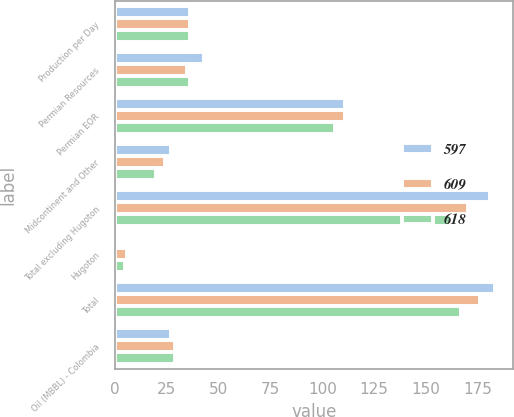Convert chart to OTSL. <chart><loc_0><loc_0><loc_500><loc_500><stacked_bar_chart><ecel><fcel>Production per Day<fcel>Permian Resources<fcel>Permian EOR<fcel>Midcontinent and Other<fcel>Total excluding Hugoton<fcel>Hugoton<fcel>Total<fcel>Oil (MBBL) - Colombia<nl><fcel>597<fcel>36<fcel>43<fcel>111<fcel>27<fcel>181<fcel>2<fcel>183<fcel>27<nl><fcel>609<fcel>36<fcel>35<fcel>111<fcel>24<fcel>170<fcel>6<fcel>176<fcel>29<nl><fcel>618<fcel>36<fcel>36<fcel>106<fcel>20<fcel>162<fcel>5<fcel>167<fcel>29<nl></chart> 